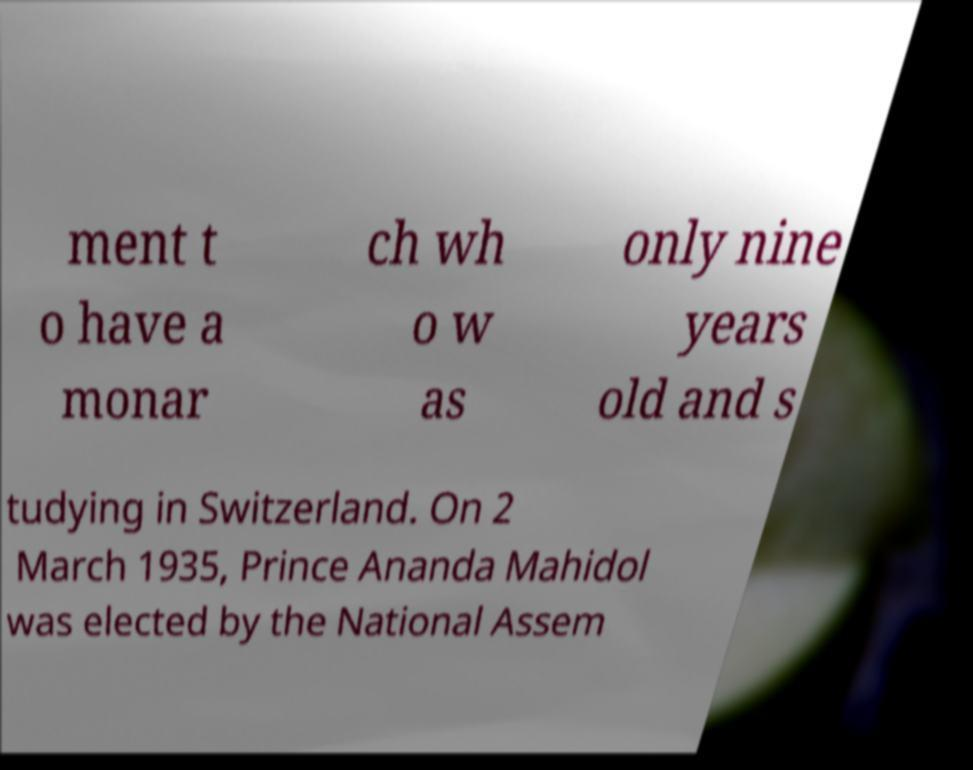There's text embedded in this image that I need extracted. Can you transcribe it verbatim? ment t o have a monar ch wh o w as only nine years old and s tudying in Switzerland. On 2 March 1935, Prince Ananda Mahidol was elected by the National Assem 